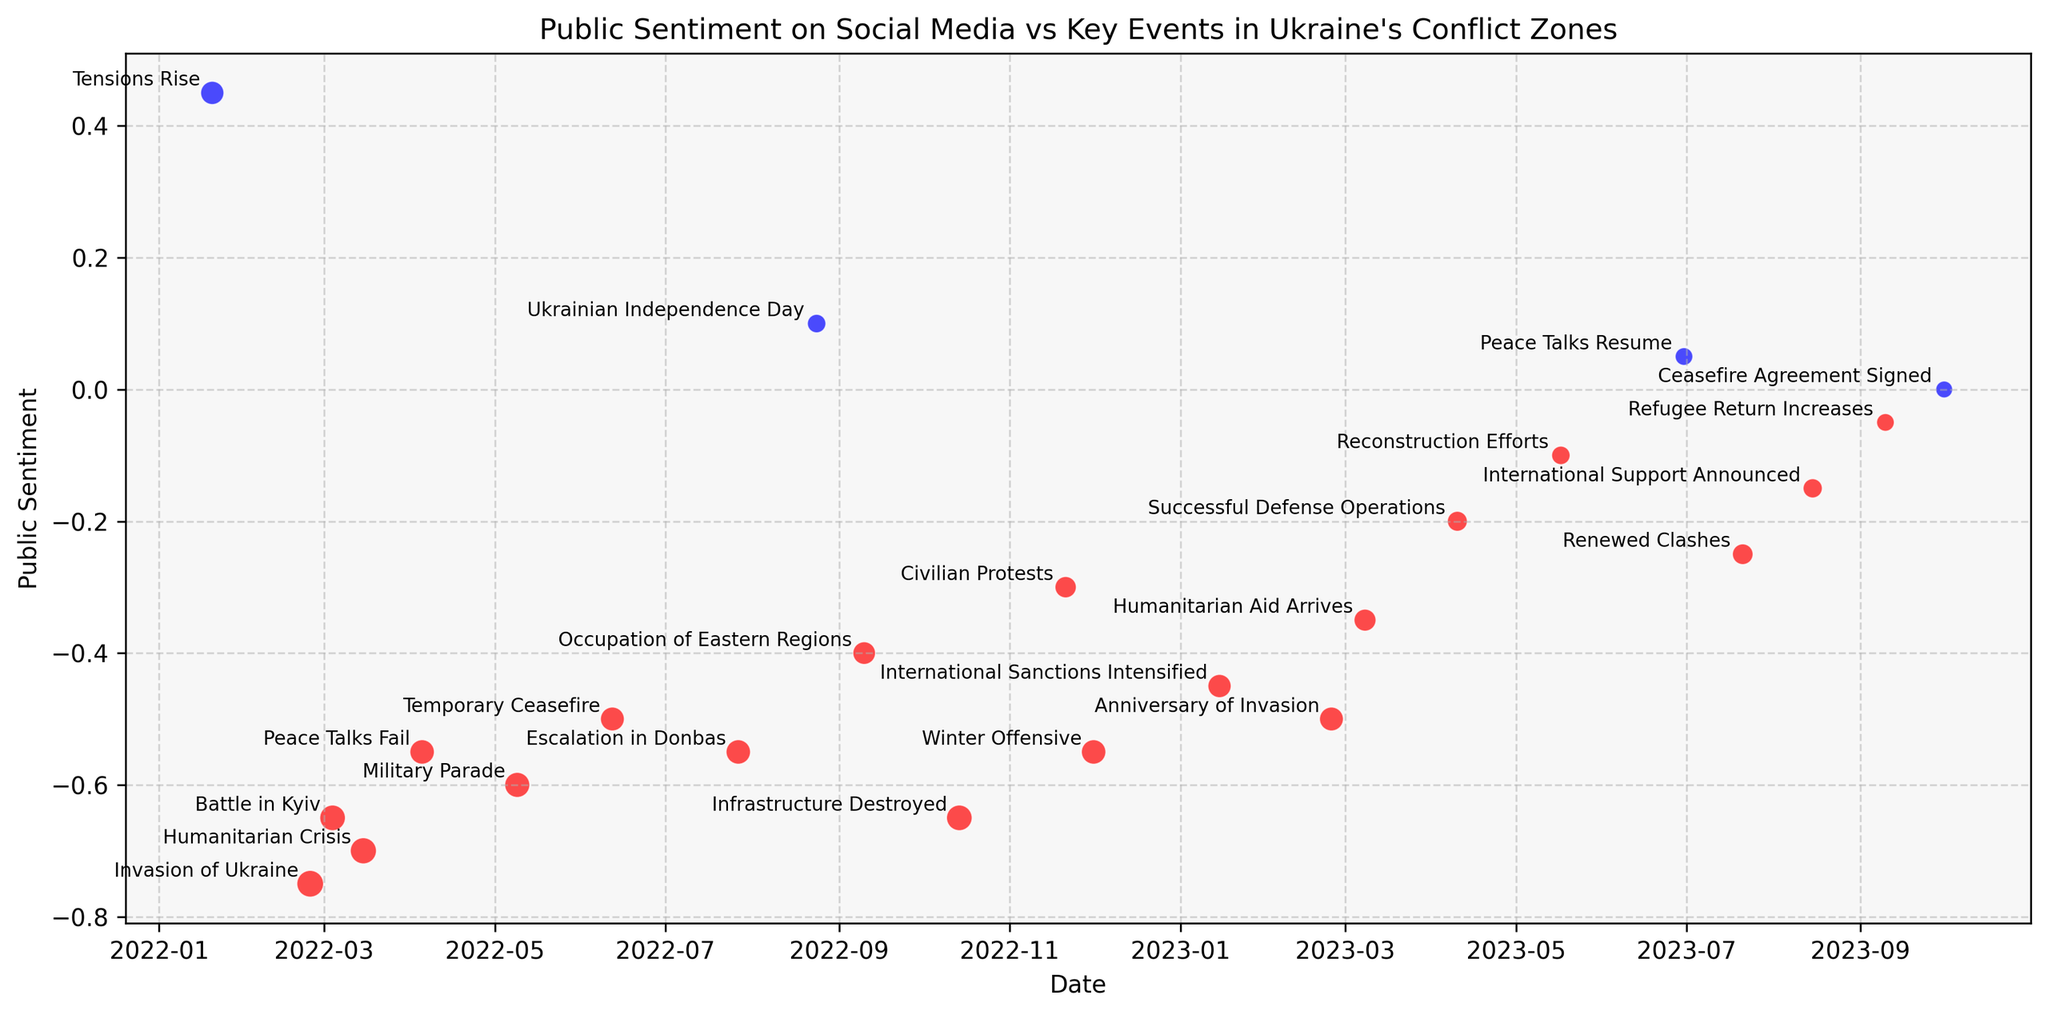What's the trend of public sentiment over time between January 2022 and October 2023? To determine the trend, observe the general movement of the data points on the y-axis from the beginning to the end of the timeline on the x-axis. Initially, public sentiment is relatively neutral but dips drastically around February 2022 with the invasion of Ukraine, then shows a gradual recovery with some fluctuations, reaching a near-neutral sentiment by October 2023.
Answer: Overall decreasing with fluctuations Which event corresponded to the highest negative public sentiment? Identify the lowest point on the y-axis (representing public sentiment) and note the corresponding event. The lowest sentiment is recorded on February 24, 2022.
Answer: Invasion of Ukraine How did public sentiment change from "Occupation of Eastern Regions" to "Civilian Protests"? Locate the data points for "Occupation of Eastern Regions" in September 2022 and "Civilian Protests" in November 2022. The sentiment changed from -0.40 to -0.30, indicating a slight improvement.
Answer: Improved by 0.10 What is the visual representation of the sentiments that are greater than zero? The data points with positive sentiments are colored blue. They include the sentiments on January 20, 2022 (0.45), August 24, 2022 (0.10), June 30, 2023 (0.05), September 10, 2023 (-0.05) and October 1, 2023 (0.00).
Answer: Blue points Compare the public sentiment between the "Battle in Kyiv" and "Humanitarian Aid Arrives" events. Locate the points for "Battle in Kyiv" in March 2022 and "Humanitarian Aid Arrives" in March 2023. The sentiment for "Battle in Kyiv" is -0.65 while for "Humanitarian Aid Arrives" it is -0.35, indicating that sentiment improved significantly.
Answer: Improved by 0.30 Which key event is associated with the smallest (negative) sentiment change between two consecutive points? Calculate the difference in sentiment between each pair of consecutive events. The smallest change is between "International Support Announced" (-0.15) and "Refugee Return Increases" (-0.05) with a change of 0.10.
Answer: International Support Announced to Refugee Return Increases How does the visual size of the points correlate with public sentiment values? Notice that the sizes of the scatter points vary and are indicative of sentiment magnitude (absolute value). Larger points correspond to larger magnitude of sentiment whether positive or negative, and smaller points correspond to sentiment values closer to zero.
Answer: Larger sizes indicate stronger sentiment What color is used to represent negative public sentiment and what does this signify? Negative sentiment points are colored red. This signifies general disapproval or negative reaction from the public on social media.
Answer: Red What is the public sentiment on Ukrainian Independence Day on August 24, 2022? Find the data point corresponding to August 24, 2022, and note the y-axis value. The sentiment is slightly positive at 0.10.
Answer: 0.10 Which month in 2023 showed the most notable improvement in public sentiment, and which events contributed to this change? Compare the sentiments month-by-month in 2023. The most notable improvement happens in April 2023 with "Successful Defense Operations" improving sentiment from -0.35 in March to -0.20.
Answer: April 2023 